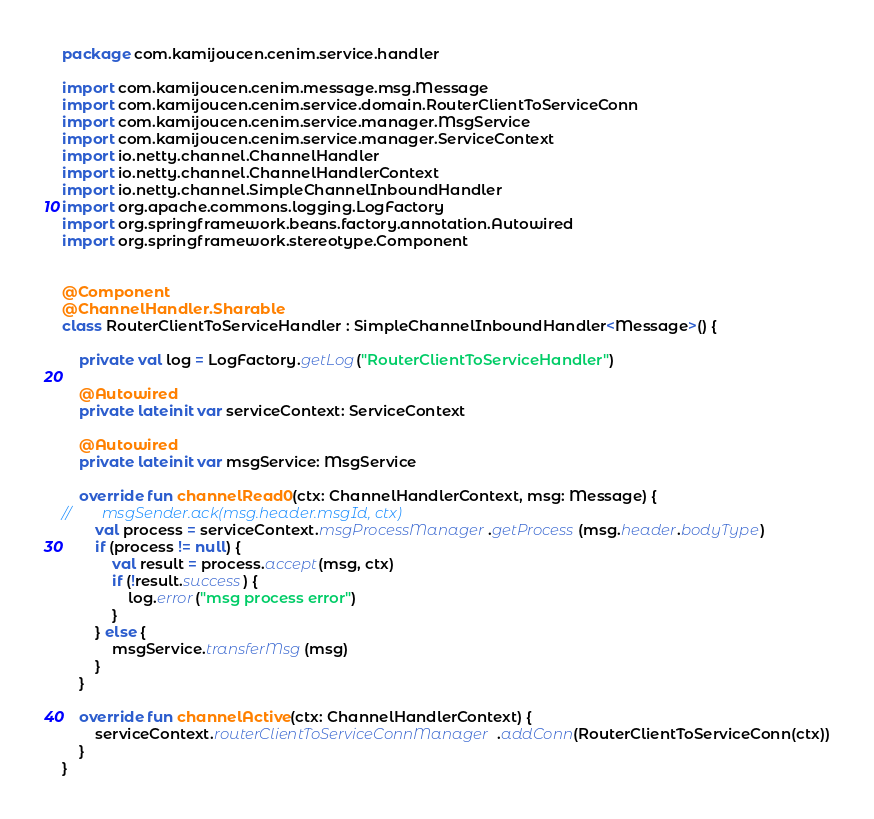Convert code to text. <code><loc_0><loc_0><loc_500><loc_500><_Kotlin_>package com.kamijoucen.cenim.service.handler

import com.kamijoucen.cenim.message.msg.Message
import com.kamijoucen.cenim.service.domain.RouterClientToServiceConn
import com.kamijoucen.cenim.service.manager.MsgService
import com.kamijoucen.cenim.service.manager.ServiceContext
import io.netty.channel.ChannelHandler
import io.netty.channel.ChannelHandlerContext
import io.netty.channel.SimpleChannelInboundHandler
import org.apache.commons.logging.LogFactory
import org.springframework.beans.factory.annotation.Autowired
import org.springframework.stereotype.Component


@Component
@ChannelHandler.Sharable
class RouterClientToServiceHandler : SimpleChannelInboundHandler<Message>() {

    private val log = LogFactory.getLog("RouterClientToServiceHandler")

    @Autowired
    private lateinit var serviceContext: ServiceContext

    @Autowired
    private lateinit var msgService: MsgService

    override fun channelRead0(ctx: ChannelHandlerContext, msg: Message) {
//        msgSender.ack(msg.header.msgId, ctx)
        val process = serviceContext.msgProcessManager.getProcess(msg.header.bodyType)
        if (process != null) {
            val result = process.accept(msg, ctx)
            if (!result.success) {
                log.error("msg process error")
            }
        } else {
            msgService.transferMsg(msg)
        }
    }

    override fun channelActive(ctx: ChannelHandlerContext) {
        serviceContext.routerClientToServiceConnManager.addConn(RouterClientToServiceConn(ctx))
    }
}</code> 